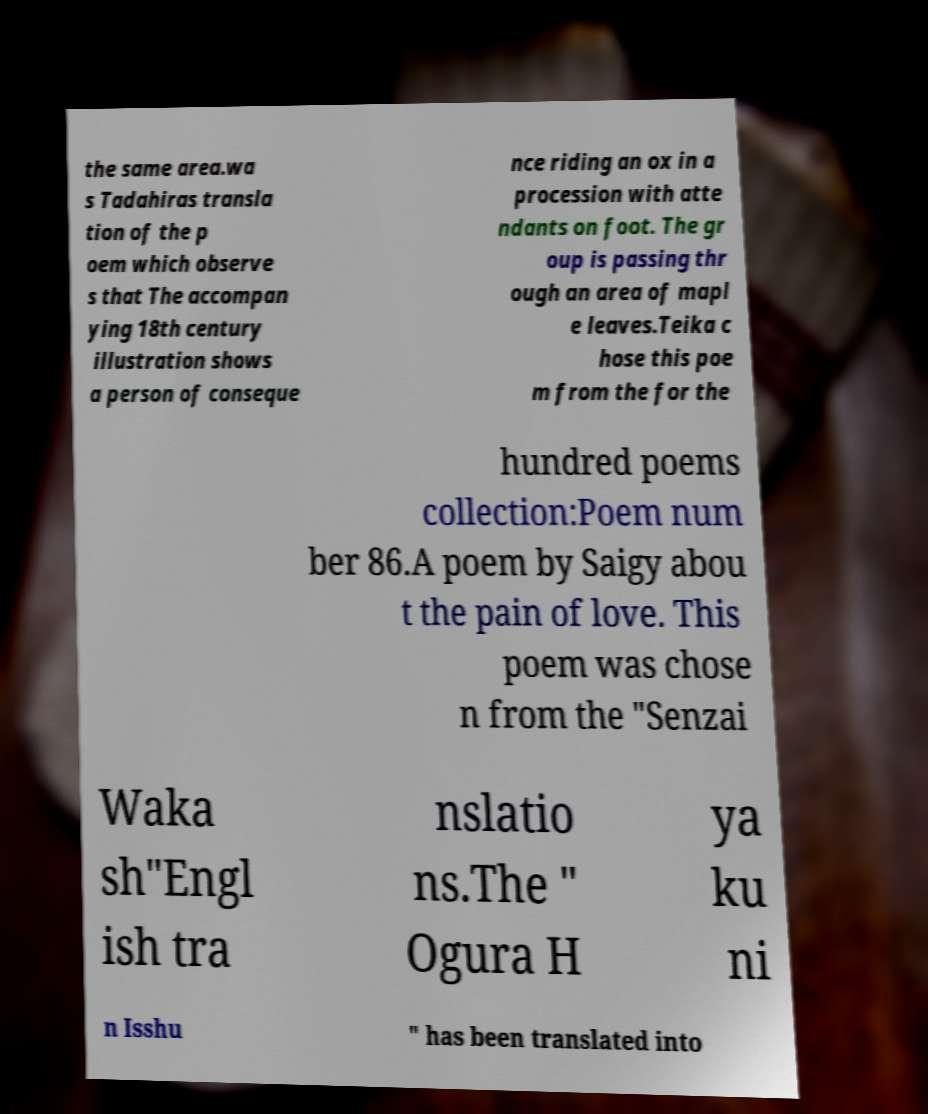Please identify and transcribe the text found in this image. the same area.wa s Tadahiras transla tion of the p oem which observe s that The accompan ying 18th century illustration shows a person of conseque nce riding an ox in a procession with atte ndants on foot. The gr oup is passing thr ough an area of mapl e leaves.Teika c hose this poe m from the for the hundred poems collection:Poem num ber 86.A poem by Saigy abou t the pain of love. This poem was chose n from the "Senzai Waka sh"Engl ish tra nslatio ns.The " Ogura H ya ku ni n Isshu " has been translated into 